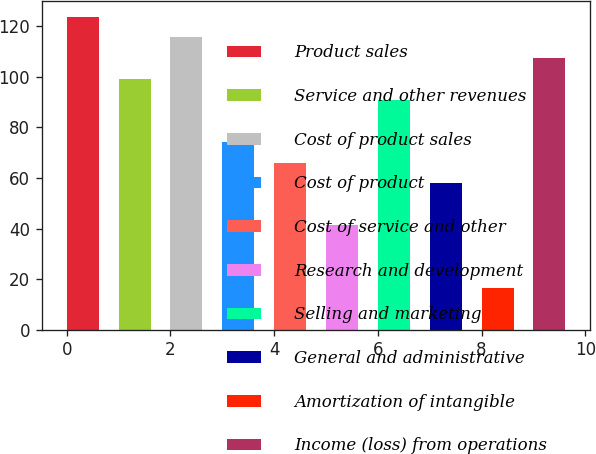Convert chart. <chart><loc_0><loc_0><loc_500><loc_500><bar_chart><fcel>Product sales<fcel>Service and other revenues<fcel>Cost of product sales<fcel>Cost of product<fcel>Cost of service and other<fcel>Research and development<fcel>Selling and marketing<fcel>General and administrative<fcel>Amortization of intangible<fcel>Income (loss) from operations<nl><fcel>123.85<fcel>99.1<fcel>115.6<fcel>74.35<fcel>66.1<fcel>41.35<fcel>90.85<fcel>57.85<fcel>16.6<fcel>107.35<nl></chart> 